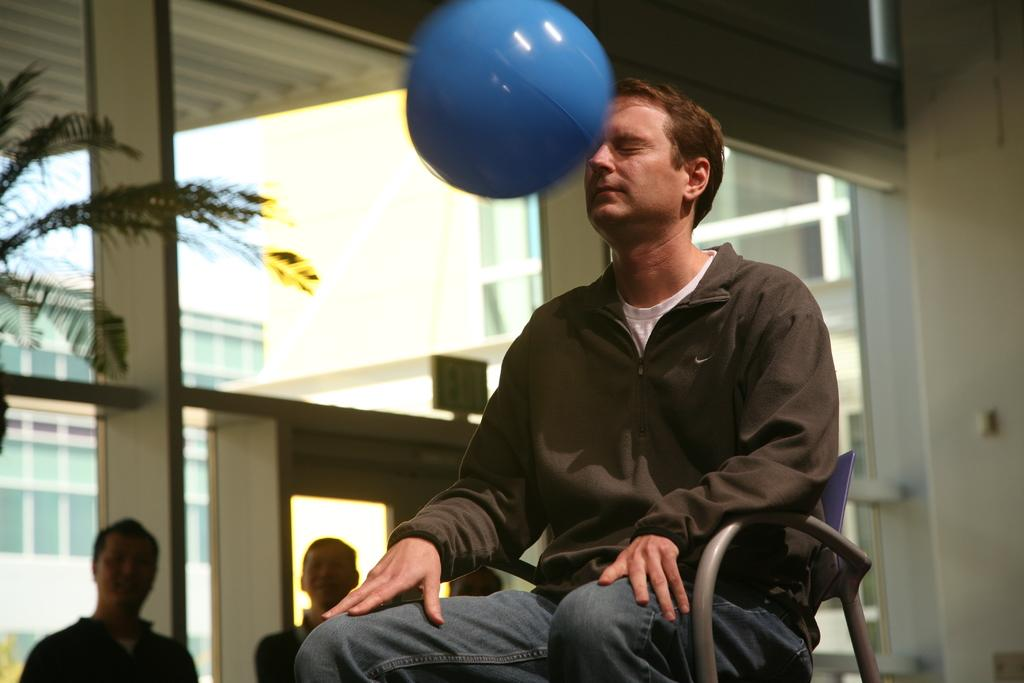Who is present in the image? There is a man in the image. What is the man doing in the image? The man is sitting on a chair. What object is near the man's face? There is a ball near the man's face. How many toes can be seen on the man's feet in the image? The image does not show the man's feet, so the number of toes cannot be determined. 